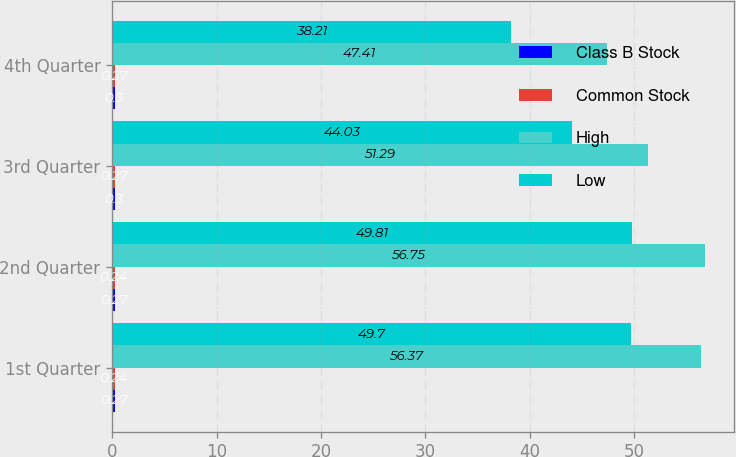Convert chart to OTSL. <chart><loc_0><loc_0><loc_500><loc_500><stacked_bar_chart><ecel><fcel>1st Quarter<fcel>2nd Quarter<fcel>3rd Quarter<fcel>4th Quarter<nl><fcel>Class B Stock<fcel>0.27<fcel>0.27<fcel>0.3<fcel>0.3<nl><fcel>Common Stock<fcel>0.24<fcel>0.24<fcel>0.27<fcel>0.27<nl><fcel>High<fcel>56.37<fcel>56.75<fcel>51.29<fcel>47.41<nl><fcel>Low<fcel>49.7<fcel>49.81<fcel>44.03<fcel>38.21<nl></chart> 